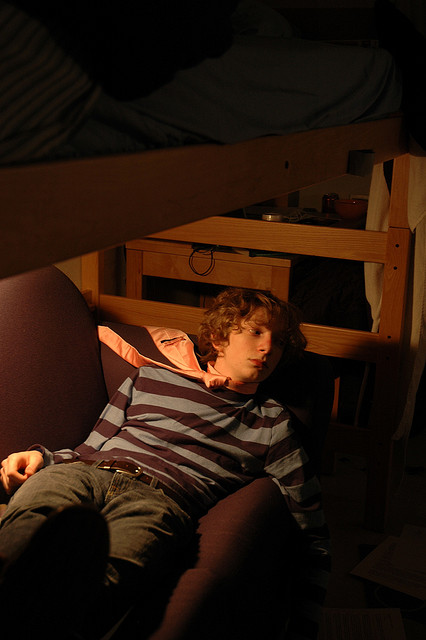<image>Where are the shoes? It is unknown where the shoes are. They might be on feet or elsewhere as it is not clearly shown. Where are the shoes? The shoes are on the feet of the person in the image. 